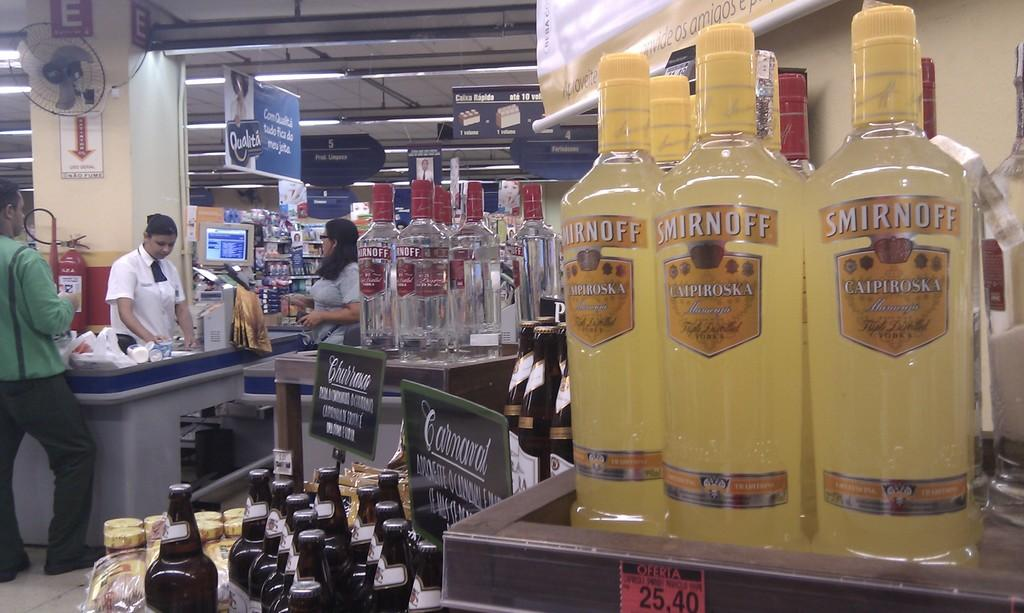What objects are placed on the shelf in the image? There are bottles placed on a shelf in the image. Where is the shelf located? The shelf is located in a market. What can be seen in the background of the image? There are people standing in the background of the image. What device is attached to the wall in the image? There is a fan attached to the wall in the image. What type of thought is being expressed by the haircut in the image? There is no haircut present in the image, so it is not possible to determine what type of thought might be expressed by it. 